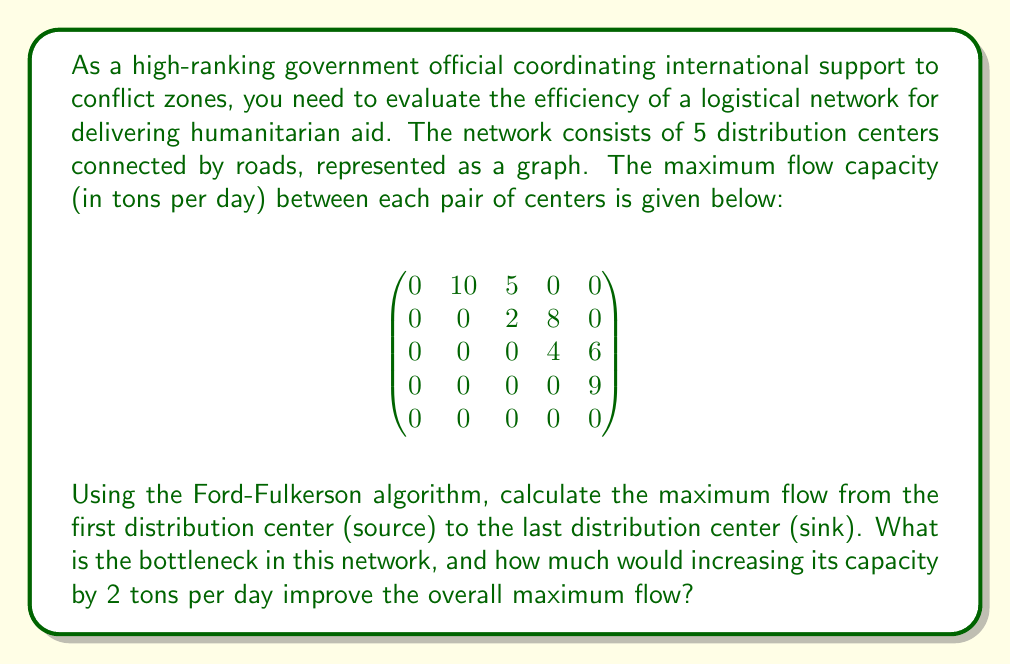Can you answer this question? To solve this problem, we'll use the Ford-Fulkerson algorithm to find the maximum flow, identify the bottleneck, and then recalculate the maximum flow after increasing the bottleneck capacity.

Step 1: Apply the Ford-Fulkerson algorithm

1. Start with zero flow.
2. Find an augmenting path from source to sink:
   Path 1: 1 -> 2 -> 4 -> 5, with a flow of 8
   Path 2: 1 -> 3 -> 5, with a flow of 5
   Path 3: 1 -> 2 -> 3 -> 5, with a flow of 2

The maximum flow is the sum of these paths: 8 + 5 + 2 = 15 tons per day.

Step 2: Identify the bottleneck

The bottleneck is the edge with the smallest capacity that, if increased, would allow for a larger maximum flow. In this case, it's the edge from node 2 to node 3, with a capacity of 2.

Step 3: Increase the bottleneck capacity

Let's increase the capacity of the edge from node 2 to node 3 by 2, making it 4.

Step 4: Recalculate the maximum flow

With the increased capacity, we can find a new augmenting path:
Path 4: 1 -> 2 -> 3 -> 5, with a flow of 2

The new maximum flow is: 15 + 2 = 17 tons per day.

Step 5: Calculate the improvement

The improvement in maximum flow is: 17 - 15 = 2 tons per day.
Answer: The maximum flow of the original network is 15 tons per day. The bottleneck is the edge from node 2 to node 3, with a capacity of 2 tons per day. Increasing this bottleneck capacity by 2 tons per day would improve the overall maximum flow by 2 tons per day, resulting in a new maximum flow of 17 tons per day. 